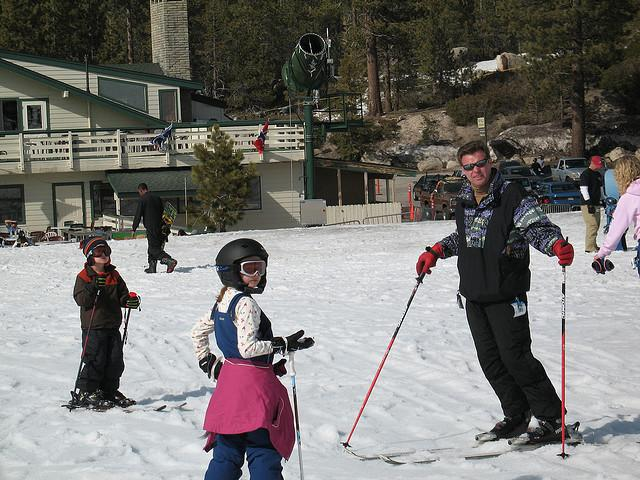What is the man in black behind the child walking away with? Please explain your reasoning. snowboard. The man in black is walking on snow at a ski resort and he's holding a snowboard. 